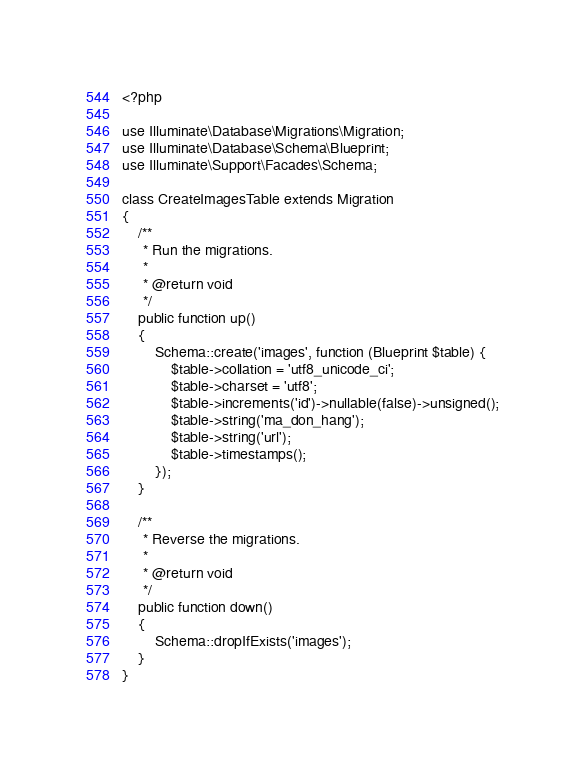Convert code to text. <code><loc_0><loc_0><loc_500><loc_500><_PHP_><?php

use Illuminate\Database\Migrations\Migration;
use Illuminate\Database\Schema\Blueprint;
use Illuminate\Support\Facades\Schema;

class CreateImagesTable extends Migration
{
    /**
     * Run the migrations.
     *
     * @return void
     */
    public function up()
    {
        Schema::create('images', function (Blueprint $table) {
            $table->collation = 'utf8_unicode_ci';
            $table->charset = 'utf8';
            $table->increments('id')->nullable(false)->unsigned();
            $table->string('ma_don_hang');
            $table->string('url');
            $table->timestamps();
        });
    }

    /**
     * Reverse the migrations.
     *
     * @return void
     */
    public function down()
    {
        Schema::dropIfExists('images');
    }
}
</code> 